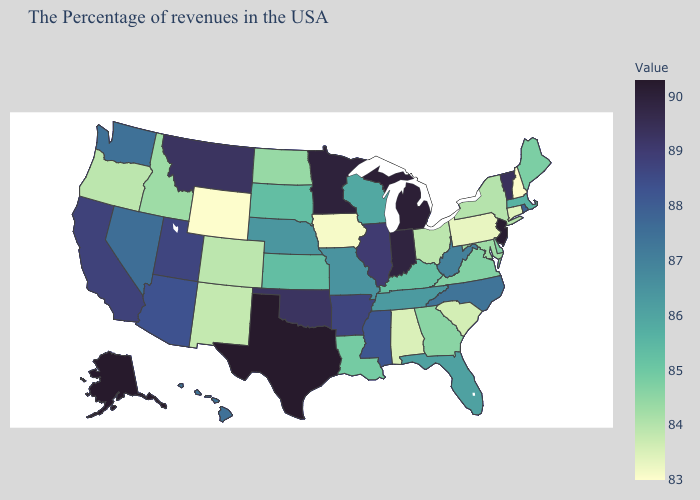Which states have the lowest value in the South?
Quick response, please. Alabama. Which states have the highest value in the USA?
Quick response, please. Texas, Alaska. Which states have the lowest value in the USA?
Short answer required. New Hampshire, Wyoming. Which states have the lowest value in the USA?
Write a very short answer. New Hampshire, Wyoming. 